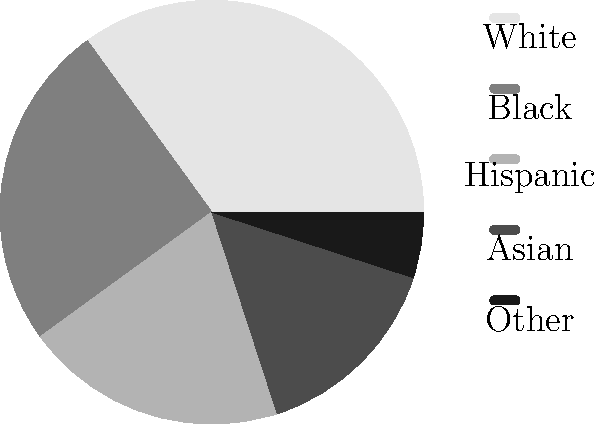As a radio broadcaster focusing on community stories, you've interviewed 200 people for a series on local experiences. The pie chart represents the demographic breakdown of your interviewees. If you aim to make your next 50 interviews more representative of the local population, which is 40% White, 30% Black, 20% Hispanic, 8% Asian, and 2% Other, how many interviewees from the Hispanic community should you include to reach this goal? To solve this problem, we need to follow these steps:

1. Calculate the current number of interviewees for each demographic:
   White: 35% of 200 = 70
   Black: 25% of 200 = 50
   Hispanic: 20% of 200 = 40
   Asian: 15% of 200 = 30
   Other: 5% of 200 = 10

2. Calculate the target number for each demographic after 50 more interviews (250 total):
   White: 40% of 250 = 100
   Black: 30% of 250 = 75
   Hispanic: 20% of 250 = 50
   Asian: 8% of 250 = 20
   Other: 2% of 250 = 5

3. Calculate the difference between the target and current numbers for Hispanic interviewees:
   Target Hispanic: 50
   Current Hispanic: 40
   Difference: 50 - 40 = 10

Therefore, to reach the goal of 20% Hispanic representation in the total 250 interviews, you should include 10 Hispanic interviewees in your next 50 interviews.
Answer: 10 